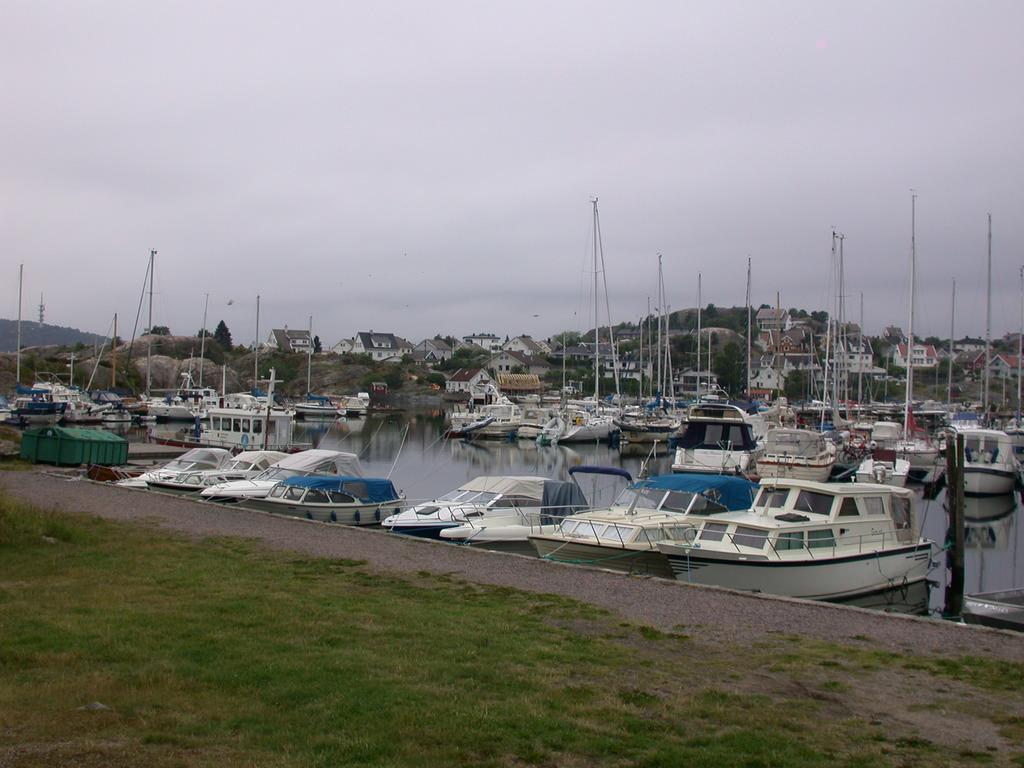Please provide a concise description of this image. This picture is clicked outside. In the center we can see the boats and some other objects in the water body and we can see the green grass, metal rods and in the background we can see the sky, houses, trees and some other objects. 